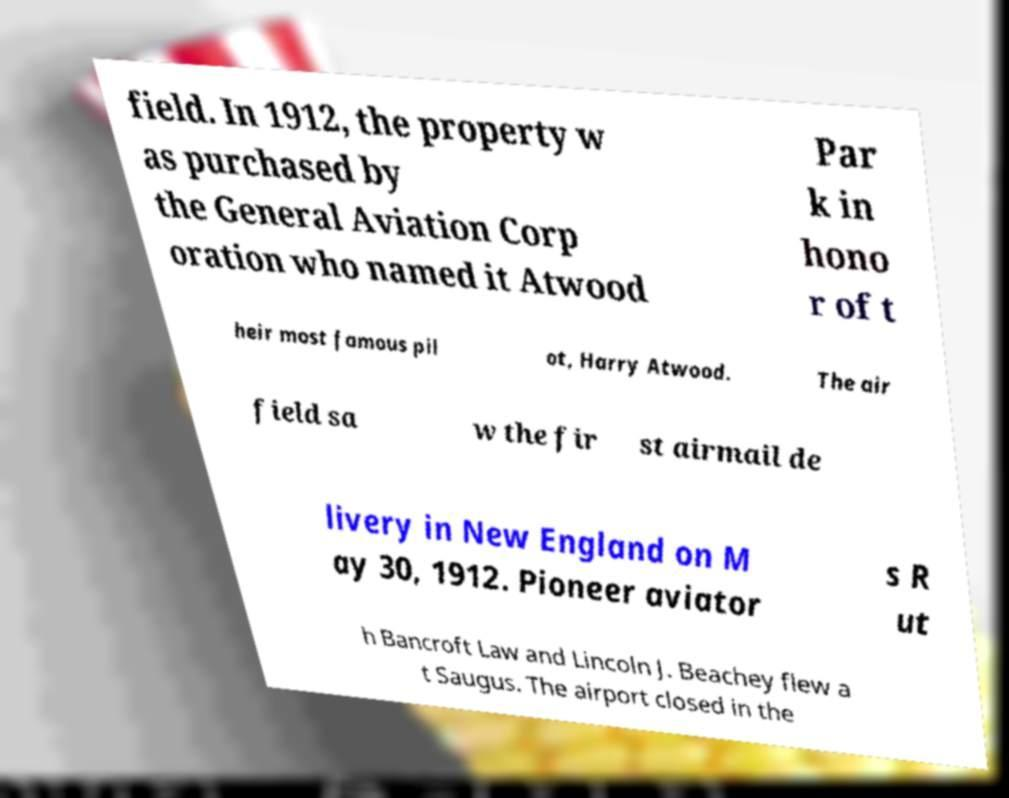Please identify and transcribe the text found in this image. field. In 1912, the property w as purchased by the General Aviation Corp oration who named it Atwood Par k in hono r of t heir most famous pil ot, Harry Atwood. The air field sa w the fir st airmail de livery in New England on M ay 30, 1912. Pioneer aviator s R ut h Bancroft Law and Lincoln J. Beachey flew a t Saugus. The airport closed in the 